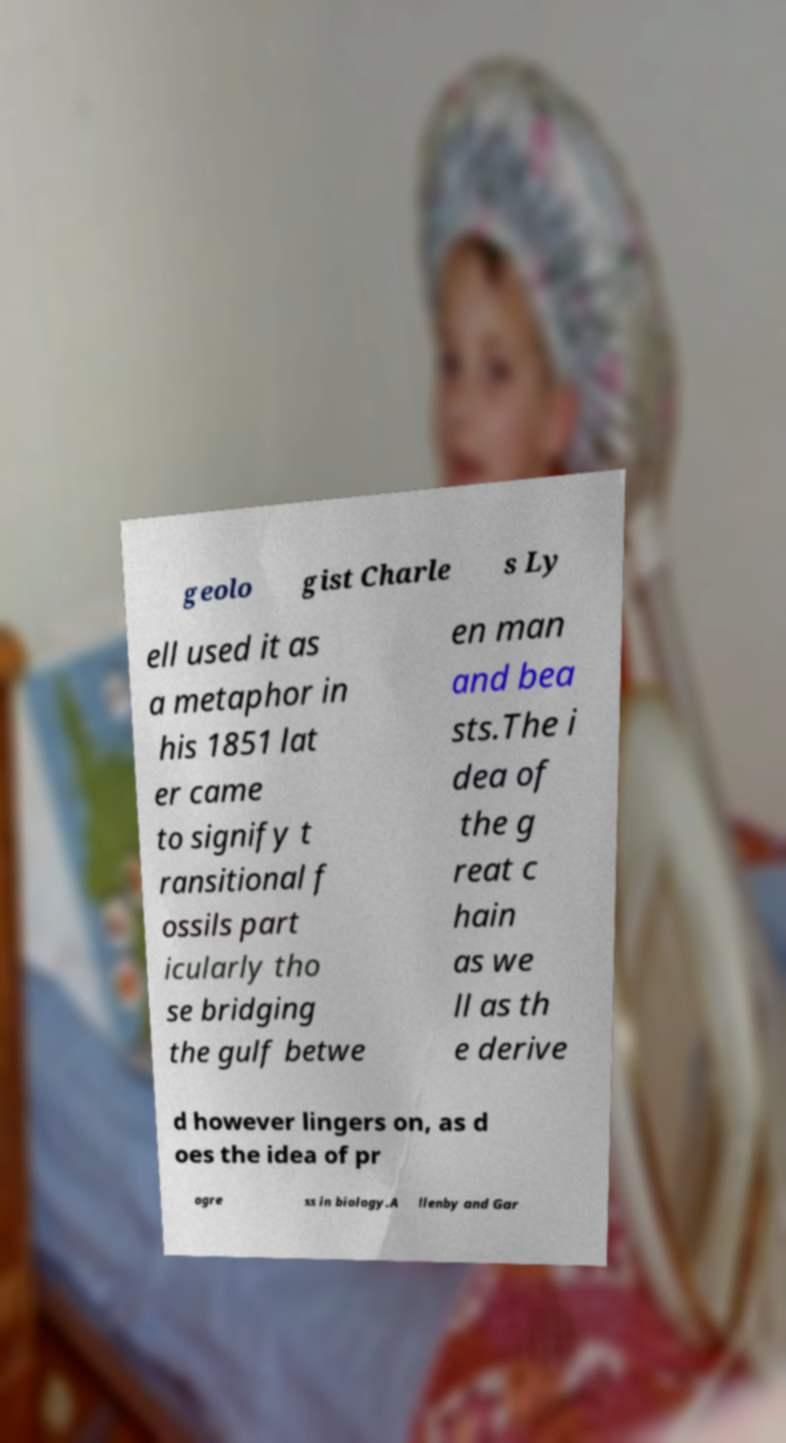Could you assist in decoding the text presented in this image and type it out clearly? geolo gist Charle s Ly ell used it as a metaphor in his 1851 lat er came to signify t ransitional f ossils part icularly tho se bridging the gulf betwe en man and bea sts.The i dea of the g reat c hain as we ll as th e derive d however lingers on, as d oes the idea of pr ogre ss in biology.A llenby and Gar 